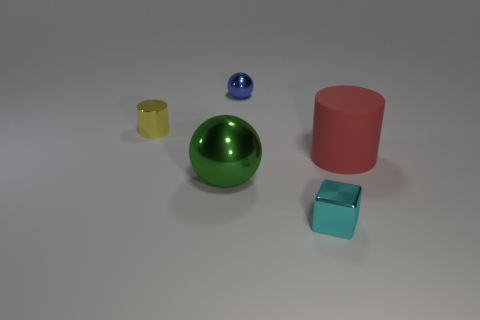How many other things are there of the same material as the small cyan cube?
Your answer should be compact. 3. Is the number of tiny metal balls to the right of the block the same as the number of big green metal things that are right of the green shiny sphere?
Your answer should be compact. Yes. There is a ball that is in front of the red matte thing; what is it made of?
Your response must be concise. Metal. Is there any other thing that is the same size as the yellow metal cylinder?
Offer a very short reply. Yes. Is the number of tiny gray matte cubes less than the number of large green metallic objects?
Your answer should be very brief. Yes. What is the shape of the small metallic object that is left of the cyan cube and in front of the blue metallic ball?
Offer a terse response. Cylinder. How many big matte cylinders are there?
Your answer should be compact. 1. What is the material of the sphere in front of the cylinder left of the cylinder that is right of the cyan metal thing?
Keep it short and to the point. Metal. How many tiny objects are to the left of the shiny sphere that is in front of the small yellow cylinder?
Provide a succinct answer. 1. What is the color of the other object that is the same shape as the red object?
Keep it short and to the point. Yellow. 